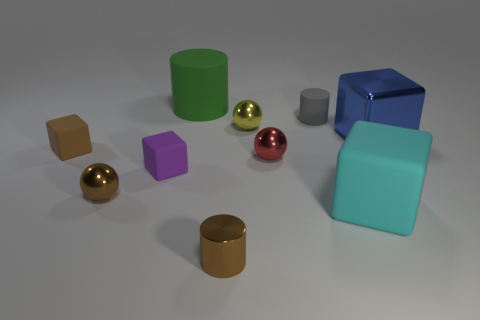Is there any object that stands out in terms of color? The red sphere stands out due to its vibrant color. It contrasts strongly with the other, more muted colors present in the scene. 